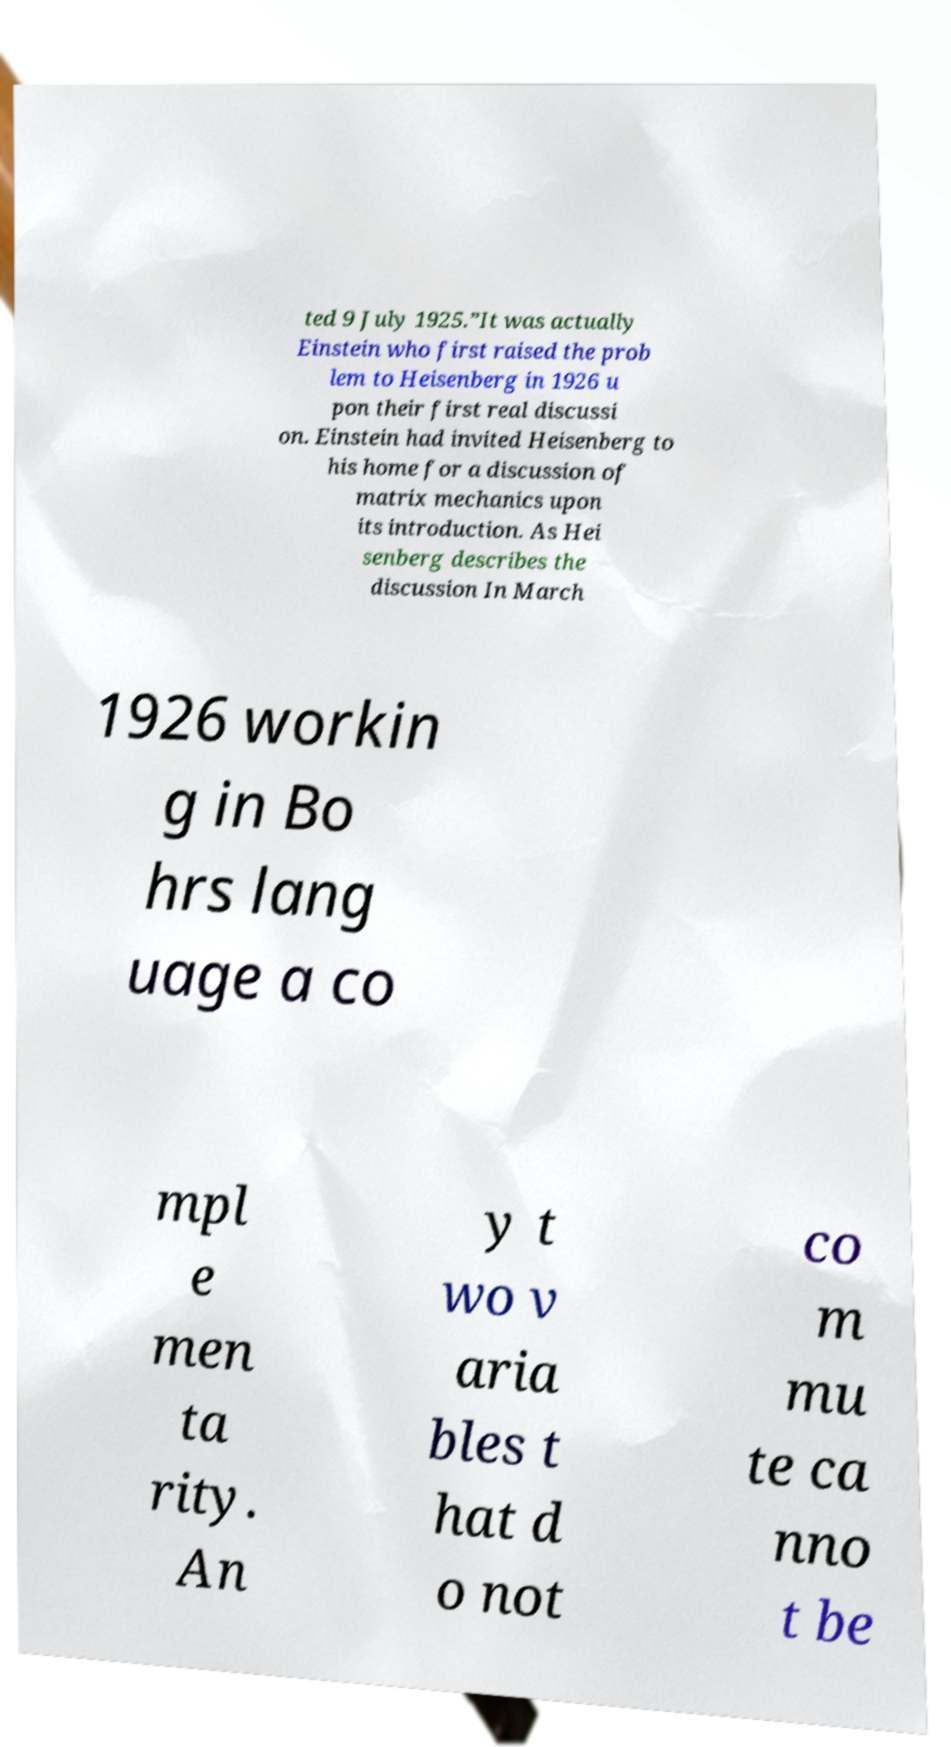There's text embedded in this image that I need extracted. Can you transcribe it verbatim? ted 9 July 1925.”It was actually Einstein who first raised the prob lem to Heisenberg in 1926 u pon their first real discussi on. Einstein had invited Heisenberg to his home for a discussion of matrix mechanics upon its introduction. As Hei senberg describes the discussion In March 1926 workin g in Bo hrs lang uage a co mpl e men ta rity. An y t wo v aria bles t hat d o not co m mu te ca nno t be 